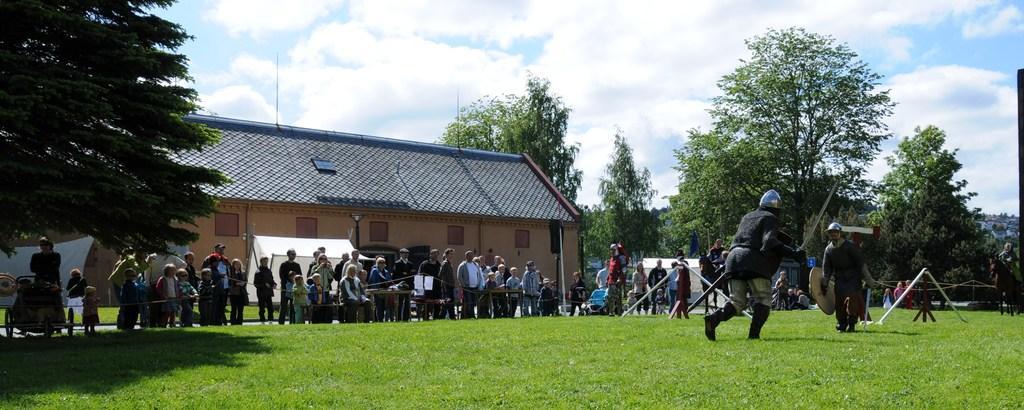Could you give a brief overview of what you see in this image? In this image I can see some grass on the ground and few persons wearing black colored dress and blue colored helmets are standing. I can see few metal poles, few person standing, few persons sitting on benches, few trees and few buildings. In the background I can see the sky. 